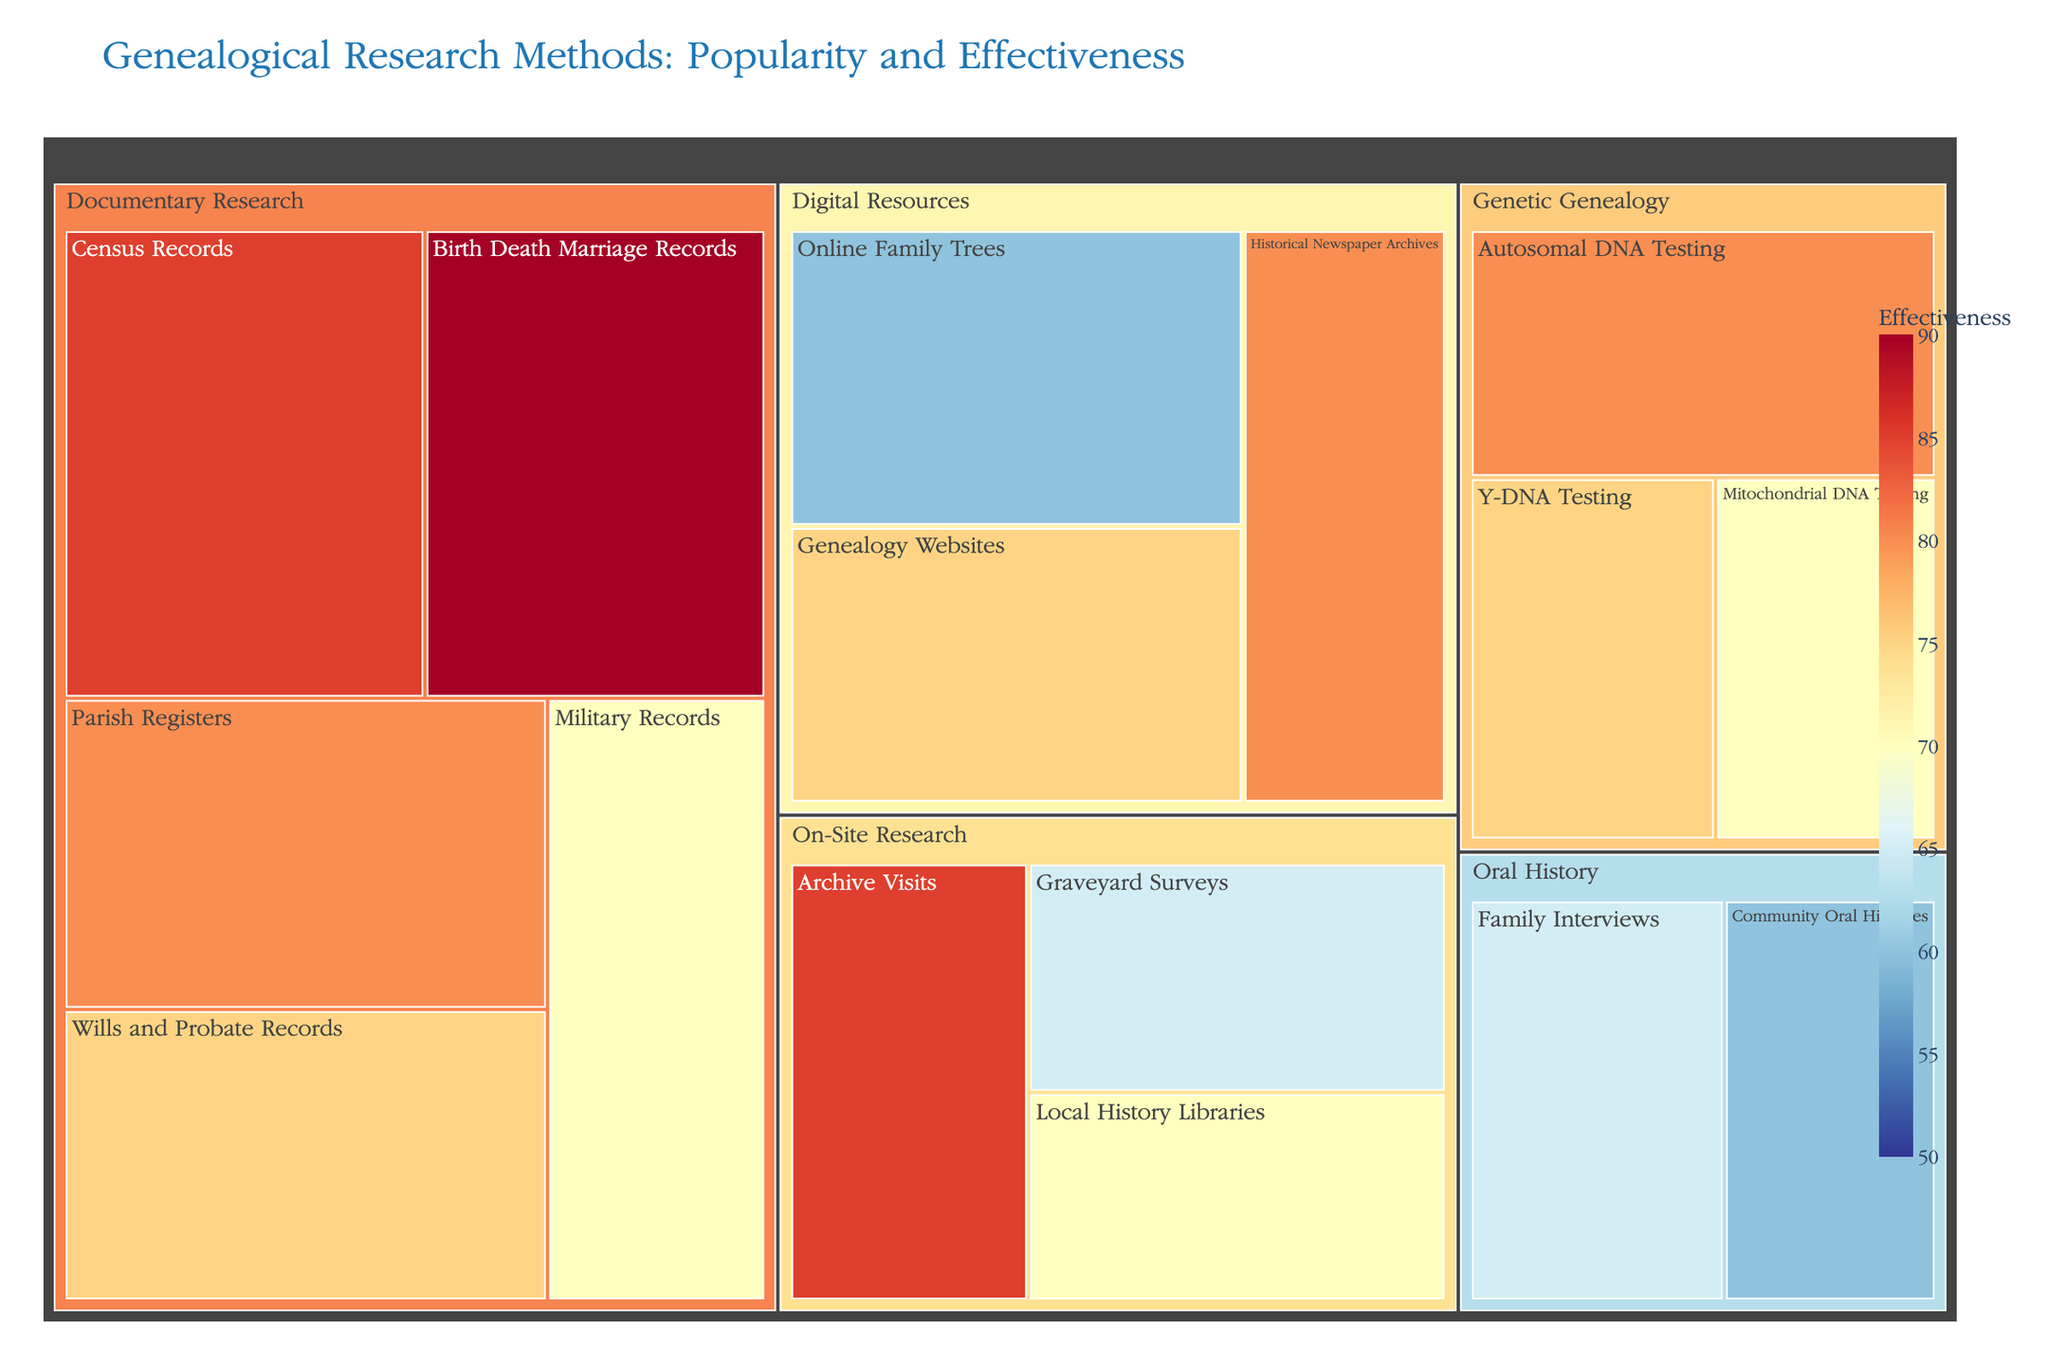What is the most popular genealogical research method according to the treemap? According to the treemap, the popularity of each method is indicated by the size of its area. Census Records in Documentary Research appears largest, signaling it is the most popular method.
Answer: Census Records Which research category has the highest average effectiveness? To find the category with the highest average effectiveness, calculate the average effectiveness of each category. Documentary Research: (85+90+80+75+70)/5 = 80, Genetic Genealogy: (80+75+70)/3 = 75, On-Site Research: (85+65+70)/3 = 73.33, Digital Resources: (60+75+80)/3 = 71.67, Oral History: (65+60)/2 = 62.5. Documentary Research has the highest average effectiveness.
Answer: Documentary Research Which method within the Oral History category is more popular? In the Oral History category, compare the popularity of Family Interviews (60) and Community Oral Histories (50). Family Interviews are more popular.
Answer: Family Interviews What is the difference in effectiveness between the most and least effective methods? The most effective method is Birth Death Marriage Records with 90, and the least effective method is Community Oral Histories with 60. The difference is 90 - 60 = 30.
Answer: 30 Which category has the method with the highest effectiveness? The method with the highest effectiveness is Birth Death Marriage Records with an effectiveness of 90, which belongs to the Documentary Research category.
Answer: Documentary Research Compare the popularity of Online Family Trees and Genealogy Websites from the Digital Resources category. In the Digital Resources category, Online Family Trees have a popularity of 75 while Genealogy Websites have a popularity of 70. Online Family Trees is more popular.
Answer: Online Family Trees What is the combined popularity of the top three methods from the Documentary Research category? The top three methods by popularity in Documentary Research are Census Records (90), Birth Death Marriage Records (85), and Parish Registers (80). The combined popularity is 90 + 85 + 80 = 255.
Answer: 255 Which category does the method with the lowest popularity belong to, and what is that popularity value? The method with the lowest popularity is Mitochondrial DNA Testing with a popularity of 45, which belongs to the Genetic Genealogy category.
Answer: Genetic Genealogy, 45 How does the effectiveness of Graveyard Surveys compare to that of Military Records? The effectiveness of Graveyard Surveys is 65, whereas the effectiveness of Military Records is 70. Military Records are more effective.
Answer: Military Records 